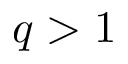Convert formula to latex. <formula><loc_0><loc_0><loc_500><loc_500>q > 1</formula> 